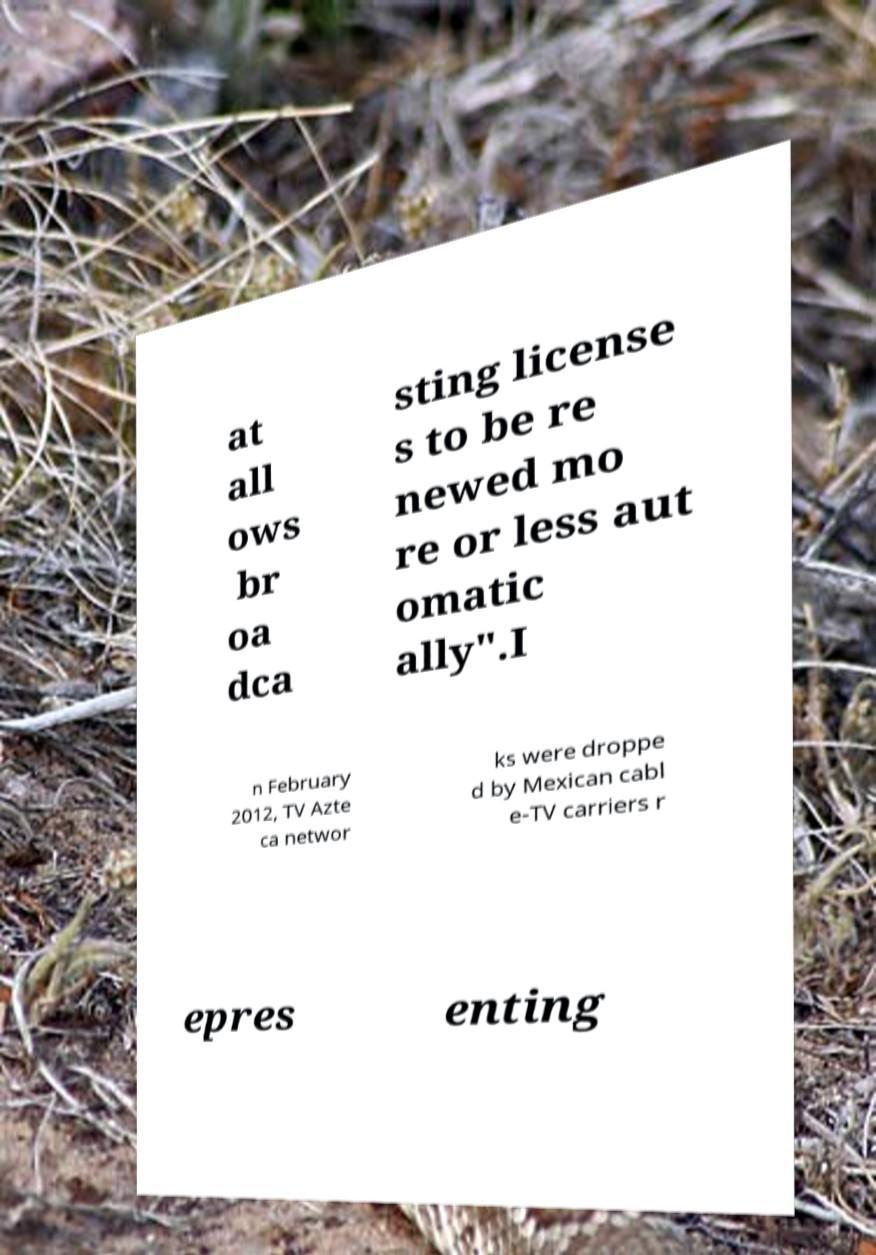Can you read and provide the text displayed in the image?This photo seems to have some interesting text. Can you extract and type it out for me? at all ows br oa dca sting license s to be re newed mo re or less aut omatic ally".I n February 2012, TV Azte ca networ ks were droppe d by Mexican cabl e-TV carriers r epres enting 